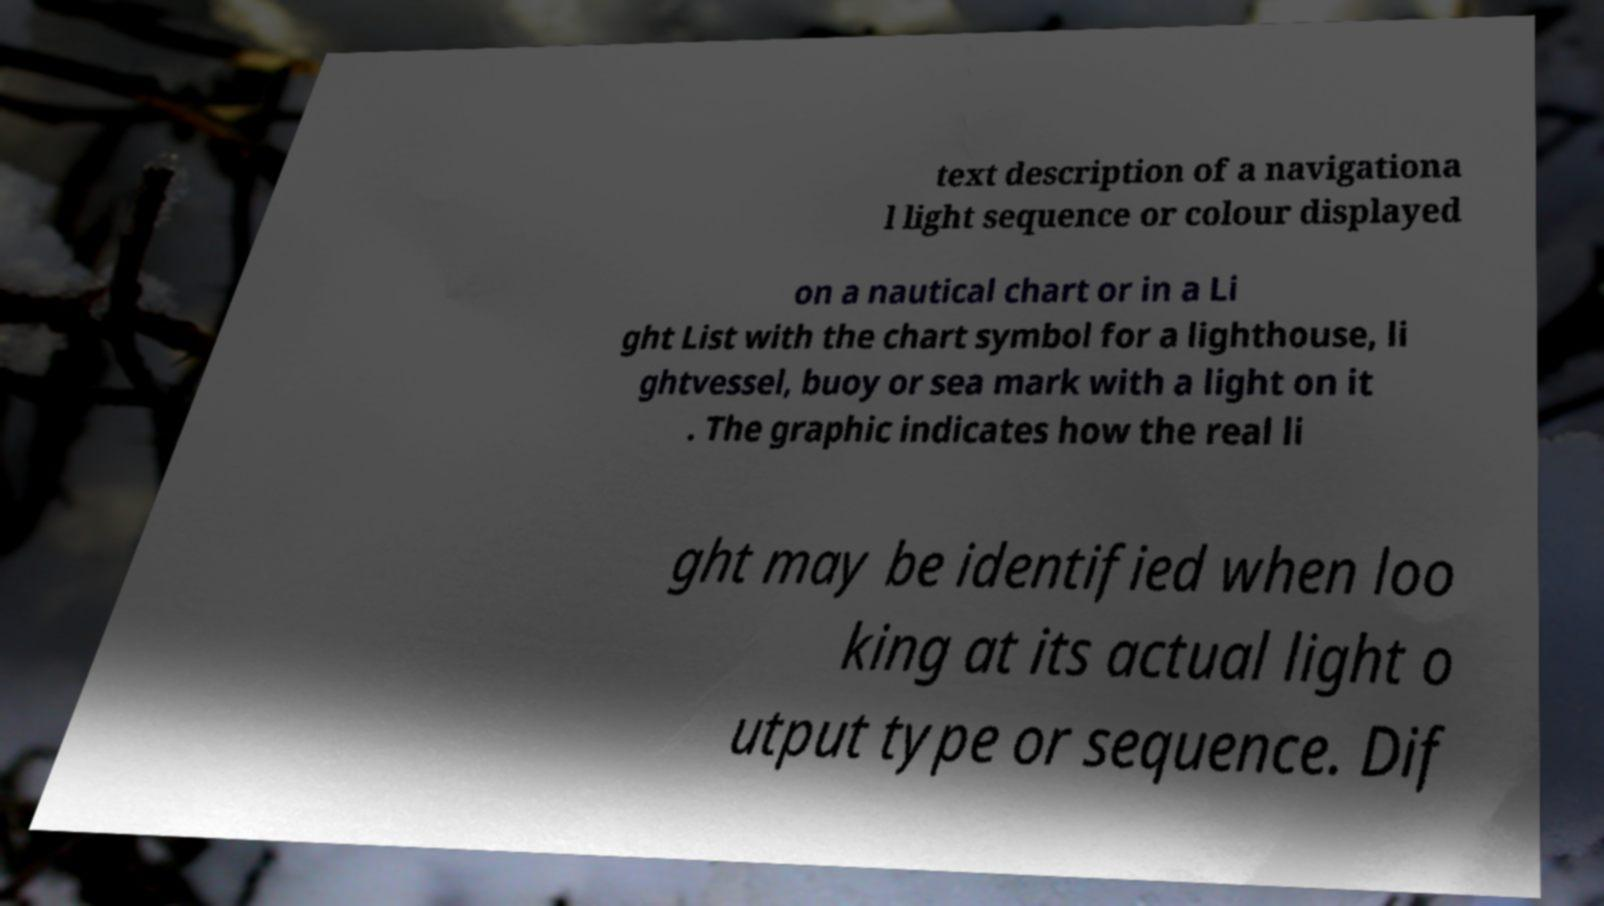Can you accurately transcribe the text from the provided image for me? text description of a navigationa l light sequence or colour displayed on a nautical chart or in a Li ght List with the chart symbol for a lighthouse, li ghtvessel, buoy or sea mark with a light on it . The graphic indicates how the real li ght may be identified when loo king at its actual light o utput type or sequence. Dif 